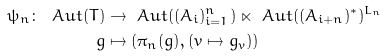Convert formula to latex. <formula><loc_0><loc_0><loc_500><loc_500>\psi _ { n } \colon \ A u t ( T ) & \rightarrow \ A u t ( ( A _ { i } ) _ { i = 1 } ^ { n } ) \ltimes \ A u t ( ( A _ { i + n } ) ^ { * } ) ^ { L _ { n } } \\ g & \mapsto ( \pi _ { n } ( g ) , ( v \mapsto g _ { v } ) )</formula> 